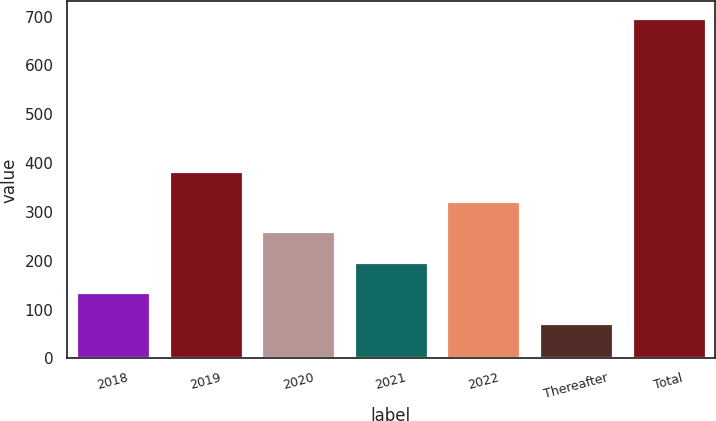<chart> <loc_0><loc_0><loc_500><loc_500><bar_chart><fcel>2018<fcel>2019<fcel>2020<fcel>2021<fcel>2022<fcel>Thereafter<fcel>Total<nl><fcel>135.3<fcel>384.5<fcel>259.9<fcel>197.6<fcel>322.2<fcel>73<fcel>696<nl></chart> 